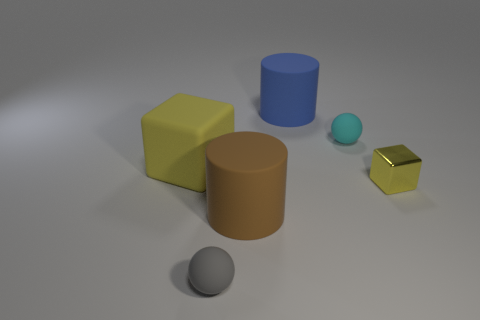What size is the rubber cylinder that is behind the large yellow cube that is in front of the cyan object?
Ensure brevity in your answer.  Large. The matte block is what color?
Your answer should be very brief. Yellow. How many yellow rubber things are on the left side of the big matte cylinder that is in front of the small metal cube?
Your answer should be compact. 1. Are there any big blue things that are in front of the large cylinder behind the big brown object?
Keep it short and to the point. No. Are there any yellow things in front of the tiny shiny cube?
Provide a succinct answer. No. Is the shape of the big thing behind the large matte block the same as  the big brown rubber object?
Your answer should be compact. Yes. How many blue matte things are the same shape as the large yellow rubber thing?
Ensure brevity in your answer.  0. Is there a tiny block that has the same material as the tiny gray object?
Offer a terse response. No. What material is the tiny sphere to the right of the tiny rubber ball in front of the cyan sphere?
Your answer should be compact. Rubber. There is a yellow thing right of the large cube; what size is it?
Keep it short and to the point. Small. 